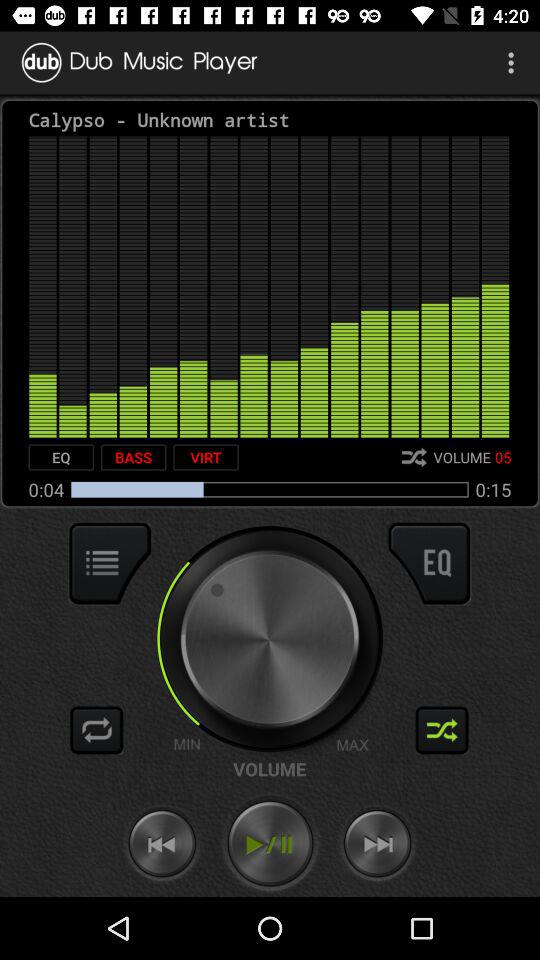How many more seconds are left in the song?
Answer the question using a single word or phrase. 11 